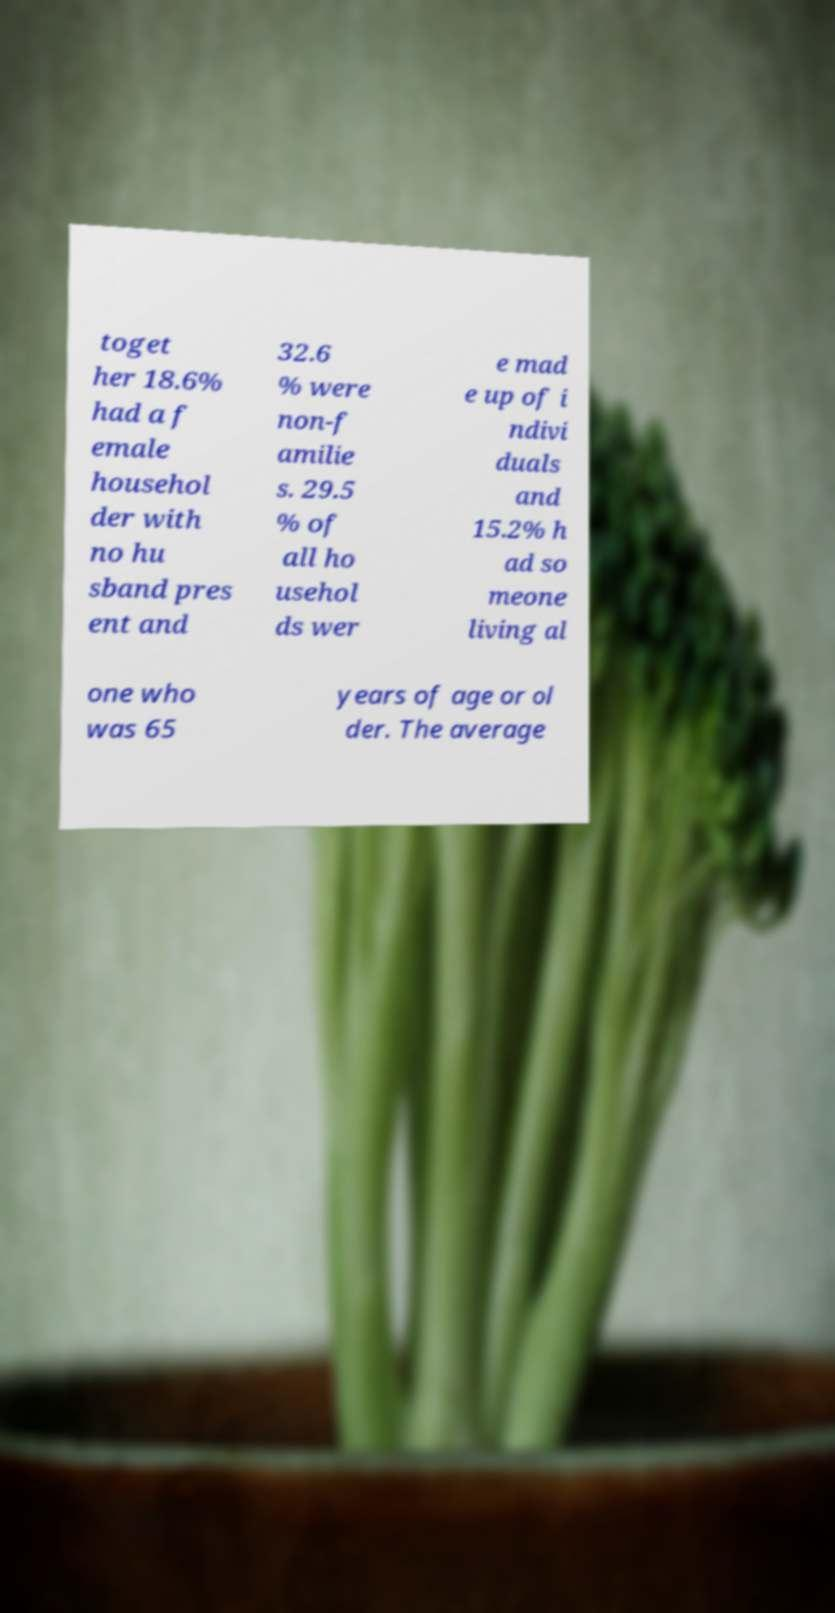Please identify and transcribe the text found in this image. toget her 18.6% had a f emale househol der with no hu sband pres ent and 32.6 % were non-f amilie s. 29.5 % of all ho usehol ds wer e mad e up of i ndivi duals and 15.2% h ad so meone living al one who was 65 years of age or ol der. The average 